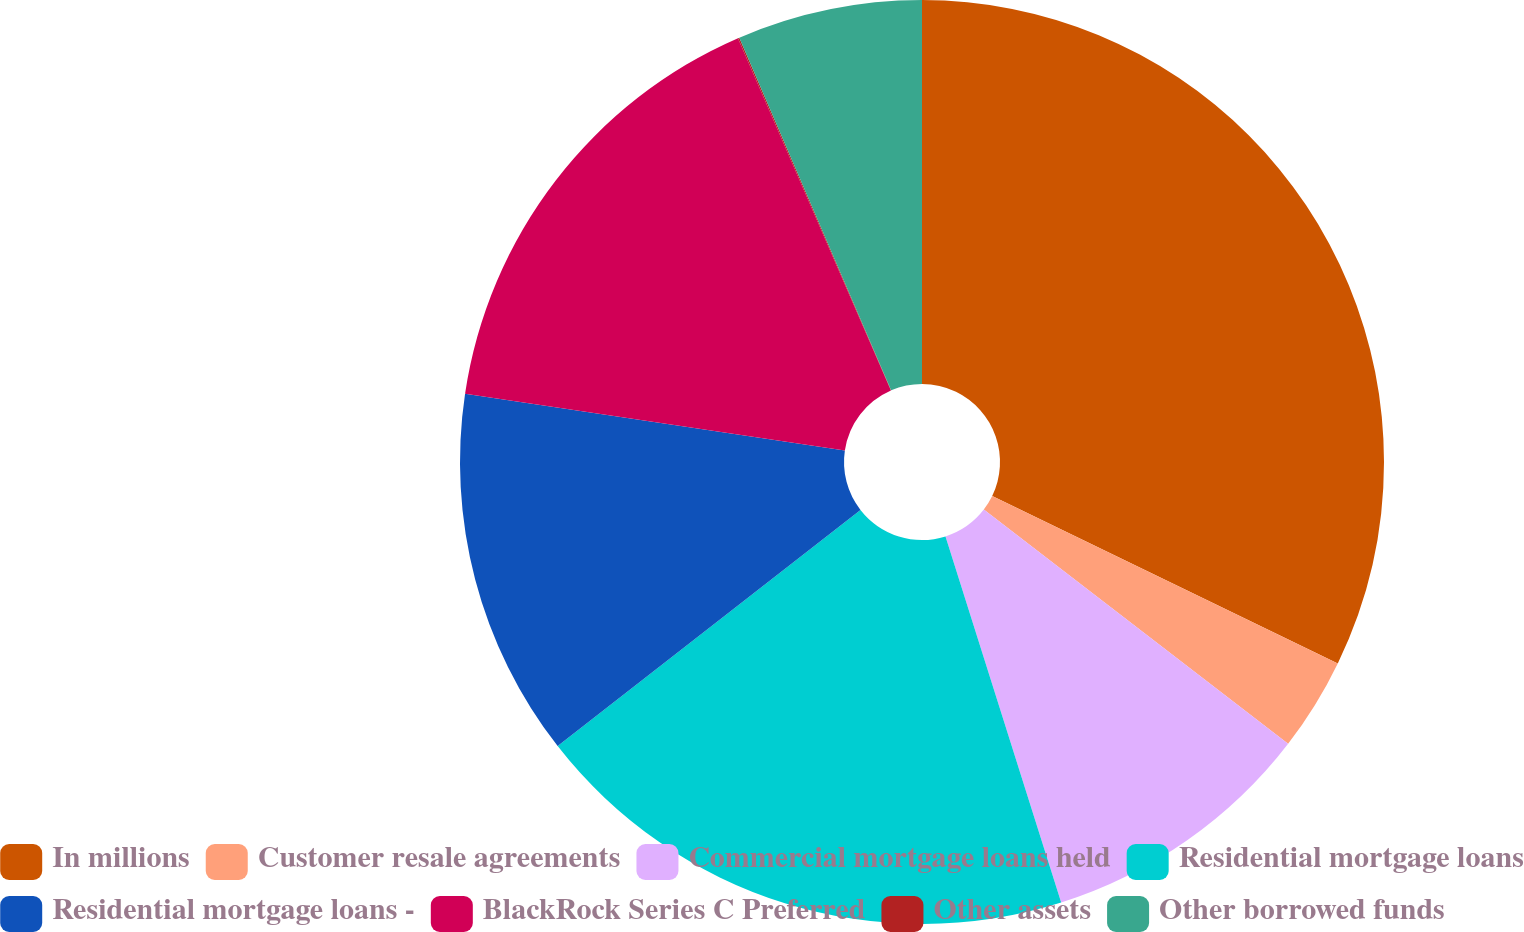Convert chart to OTSL. <chart><loc_0><loc_0><loc_500><loc_500><pie_chart><fcel>In millions<fcel>Customer resale agreements<fcel>Commercial mortgage loans held<fcel>Residential mortgage loans<fcel>Residential mortgage loans -<fcel>BlackRock Series C Preferred<fcel>Other assets<fcel>Other borrowed funds<nl><fcel>32.18%<fcel>3.26%<fcel>9.69%<fcel>19.33%<fcel>12.9%<fcel>16.12%<fcel>0.05%<fcel>6.47%<nl></chart> 